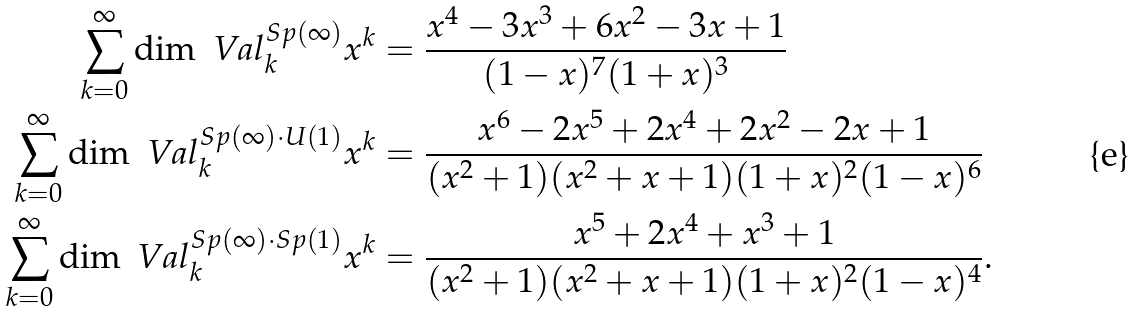Convert formula to latex. <formula><loc_0><loc_0><loc_500><loc_500>\sum _ { k = 0 } ^ { \infty } \dim \ V a l _ { k } ^ { S p ( \infty ) } x ^ { k } & = \frac { x ^ { 4 } - 3 x ^ { 3 } + 6 x ^ { 2 } - 3 x + 1 } { ( 1 - x ) ^ { 7 } ( 1 + x ) ^ { 3 } } \\ \sum _ { k = 0 } ^ { \infty } \dim \ V a l _ { k } ^ { S p ( \infty ) \cdot U ( 1 ) } x ^ { k } & = \frac { x ^ { 6 } - 2 x ^ { 5 } + 2 x ^ { 4 } + 2 x ^ { 2 } - 2 x + 1 } { ( x ^ { 2 } + 1 ) ( x ^ { 2 } + x + 1 ) ( 1 + x ) ^ { 2 } ( 1 - x ) ^ { 6 } } \\ \sum _ { k = 0 } ^ { \infty } \dim \ V a l _ { k } ^ { S p ( \infty ) \cdot S p ( 1 ) } x ^ { k } & = \frac { x ^ { 5 } + 2 x ^ { 4 } + x ^ { 3 } + 1 } { ( x ^ { 2 } + 1 ) ( x ^ { 2 } + x + 1 ) ( 1 + x ) ^ { 2 } ( 1 - x ) ^ { 4 } } .</formula> 